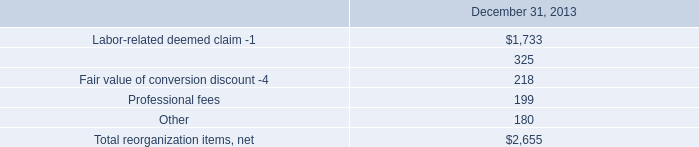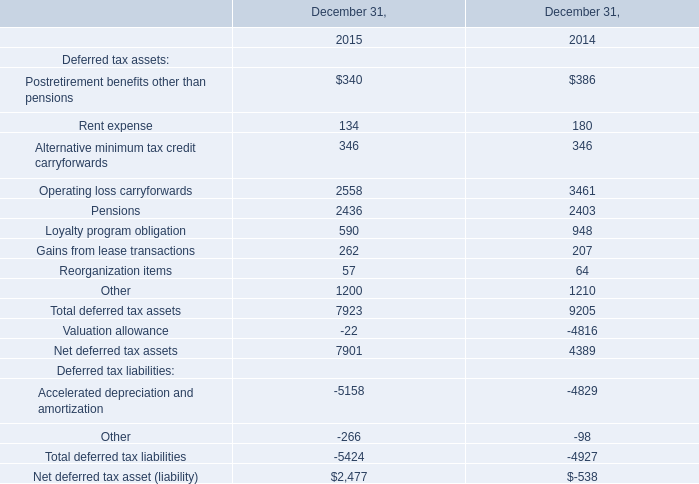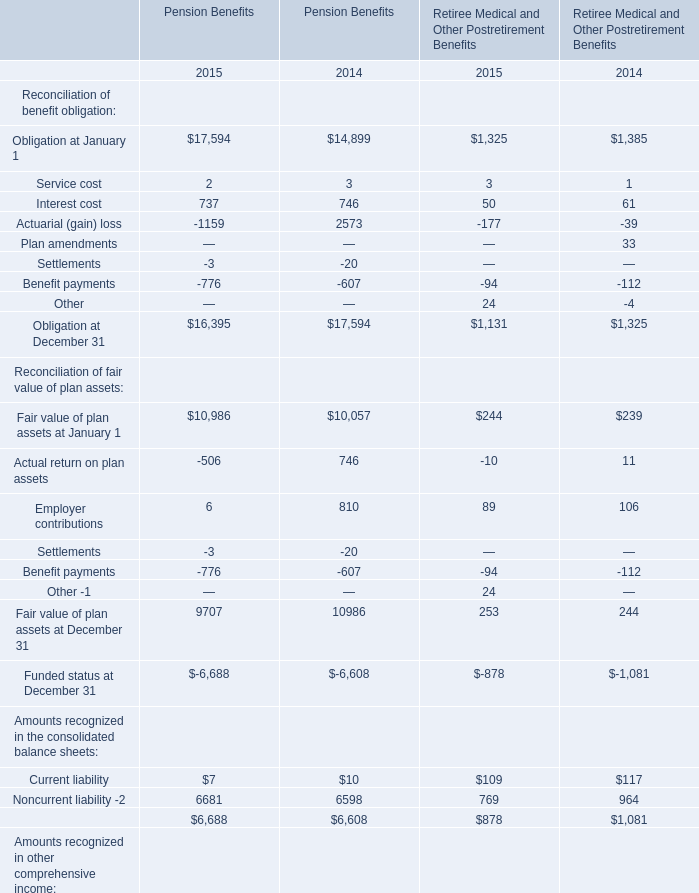what's the total amount of Operating loss carryforwards of December 31, 2014, and Obligation at January 1 of Pension Benefits 2015 ? 
Computations: (3461.0 + 17594.0)
Answer: 21055.0. 